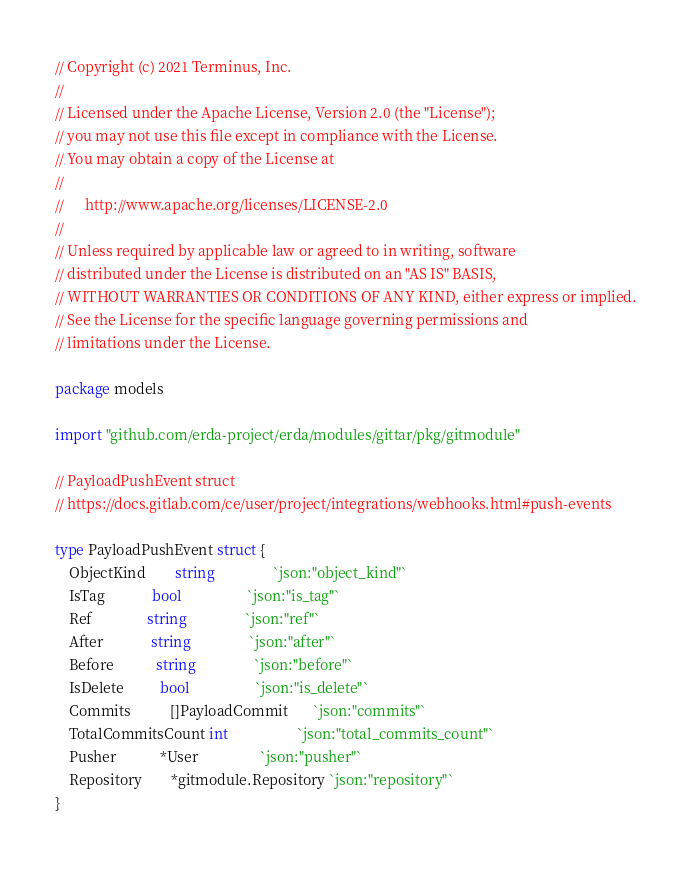<code> <loc_0><loc_0><loc_500><loc_500><_Go_>// Copyright (c) 2021 Terminus, Inc.
//
// Licensed under the Apache License, Version 2.0 (the "License");
// you may not use this file except in compliance with the License.
// You may obtain a copy of the License at
//
//      http://www.apache.org/licenses/LICENSE-2.0
//
// Unless required by applicable law or agreed to in writing, software
// distributed under the License is distributed on an "AS IS" BASIS,
// WITHOUT WARRANTIES OR CONDITIONS OF ANY KIND, either express or implied.
// See the License for the specific language governing permissions and
// limitations under the License.

package models

import "github.com/erda-project/erda/modules/gittar/pkg/gitmodule"

// PayloadPushEvent struct
// https://docs.gitlab.com/ce/user/project/integrations/webhooks.html#push-events

type PayloadPushEvent struct {
	ObjectKind        string                `json:"object_kind"`
	IsTag             bool                  `json:"is_tag"`
	Ref               string                `json:"ref"`
	After             string                `json:"after"`
	Before            string                `json:"before"`
	IsDelete          bool                  `json:"is_delete"`
	Commits           []PayloadCommit       `json:"commits"`
	TotalCommitsCount int                   `json:"total_commits_count"`
	Pusher            *User                 `json:"pusher"`
	Repository        *gitmodule.Repository `json:"repository"`
}
</code> 